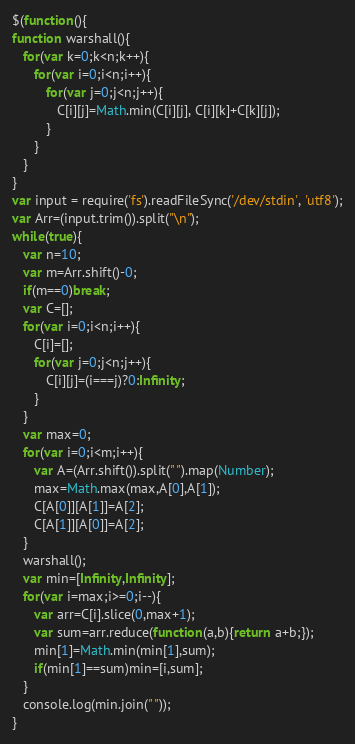Convert code to text. <code><loc_0><loc_0><loc_500><loc_500><_JavaScript_>$(function(){
function warshall(){
   for(var k=0;k<n;k++){
      for(var i=0;i<n;i++){
         for(var j=0;j<n;j++){
            C[i][j]=Math.min(C[i][j], C[i][k]+C[k][j]);
         }
      }
   }
}
var input = require('fs').readFileSync('/dev/stdin', 'utf8');
var Arr=(input.trim()).split("\n");
while(true){
   var n=10;
   var m=Arr.shift()-0;
   if(m==0)break;
   var C=[];
   for(var i=0;i<n;i++){
      C[i]=[];
      for(var j=0;j<n;j++){
         C[i][j]=(i===j)?0:Infinity;
      }
   }
   var max=0;
   for(var i=0;i<m;i++){
      var A=(Arr.shift()).split(" ").map(Number);
      max=Math.max(max,A[0],A[1]);
      C[A[0]][A[1]]=A[2];
      C[A[1]][A[0]]=A[2];
   }
   warshall();
   var min=[Infinity,Infinity];
   for(var i=max;i>=0;i--){
      var arr=C[i].slice(0,max+1);
      var sum=arr.reduce(function(a,b){return a+b;});
      min[1]=Math.min(min[1],sum);
      if(min[1]==sum)min=[i,sum];
   }
   console.log(min.join(" "));
}</code> 